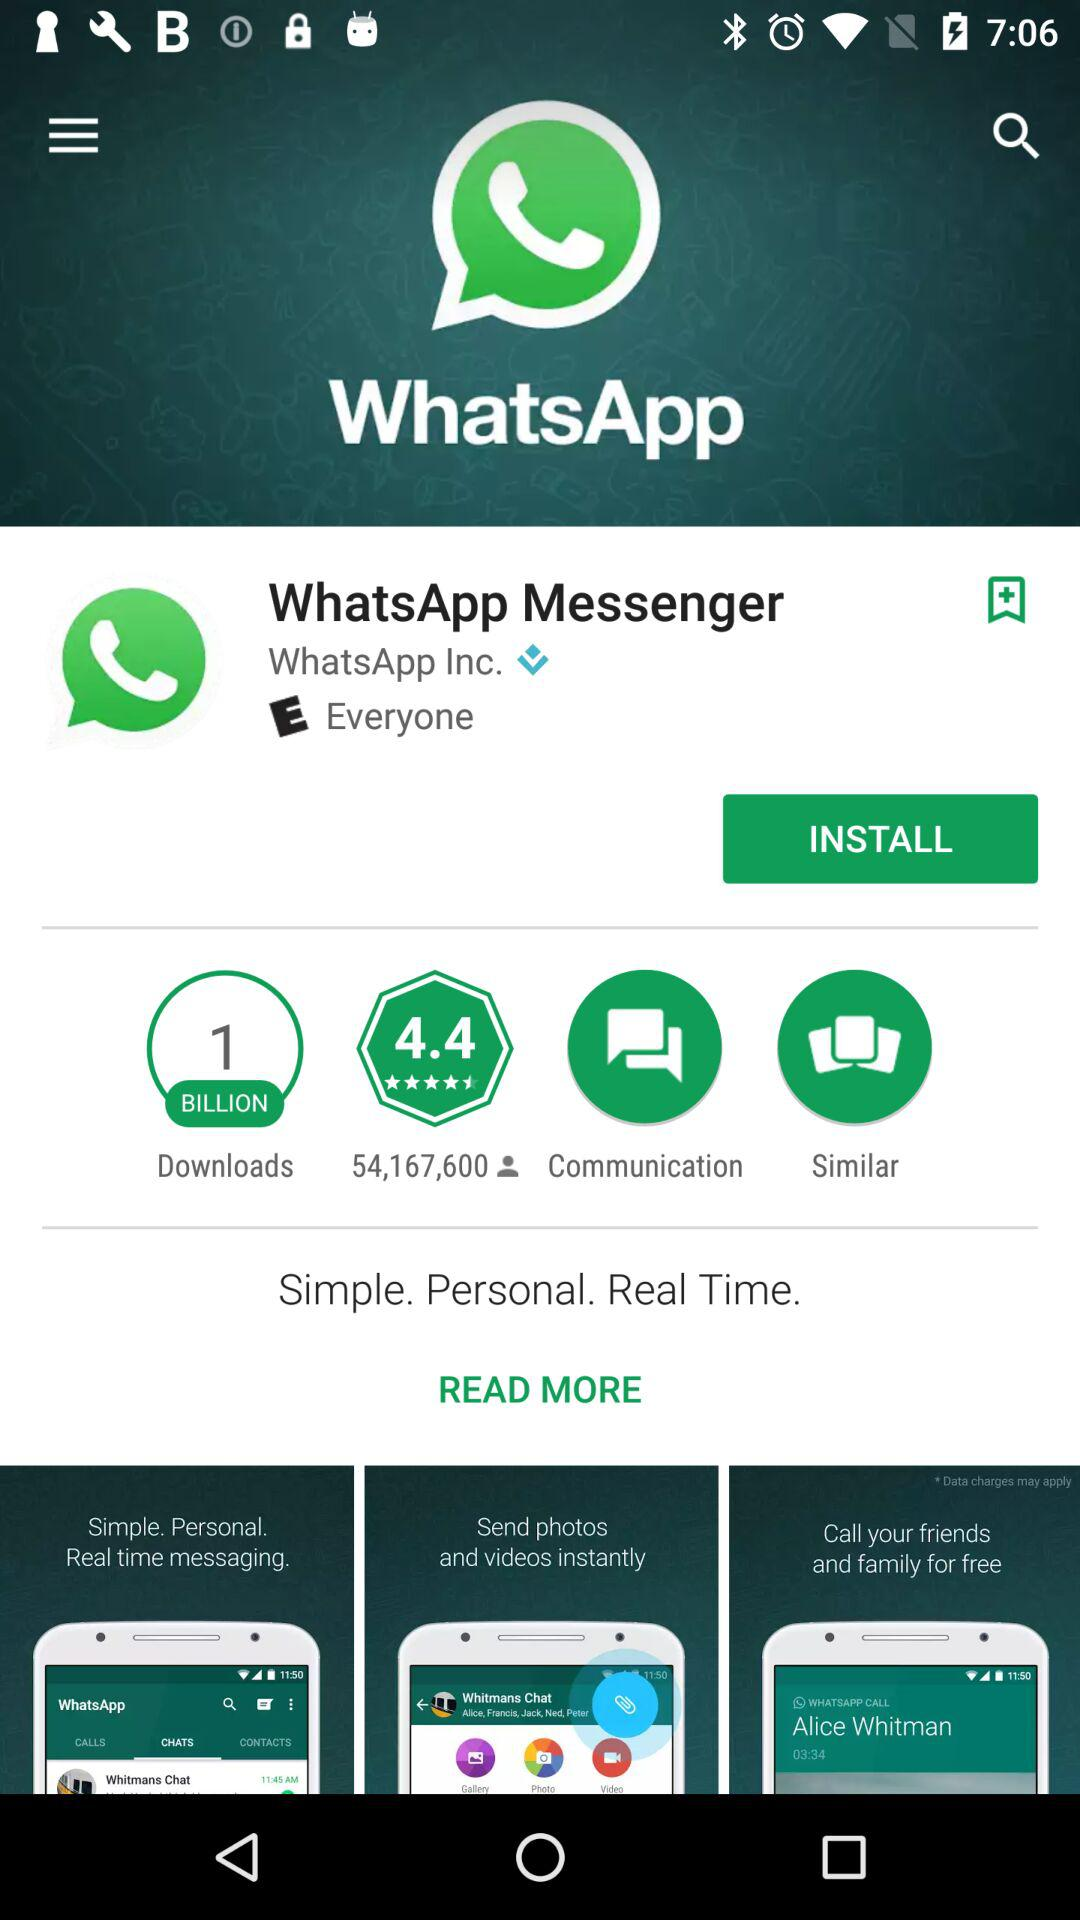What is the number of people who give ratings? The number of people who give ratings is 54,167,600. 